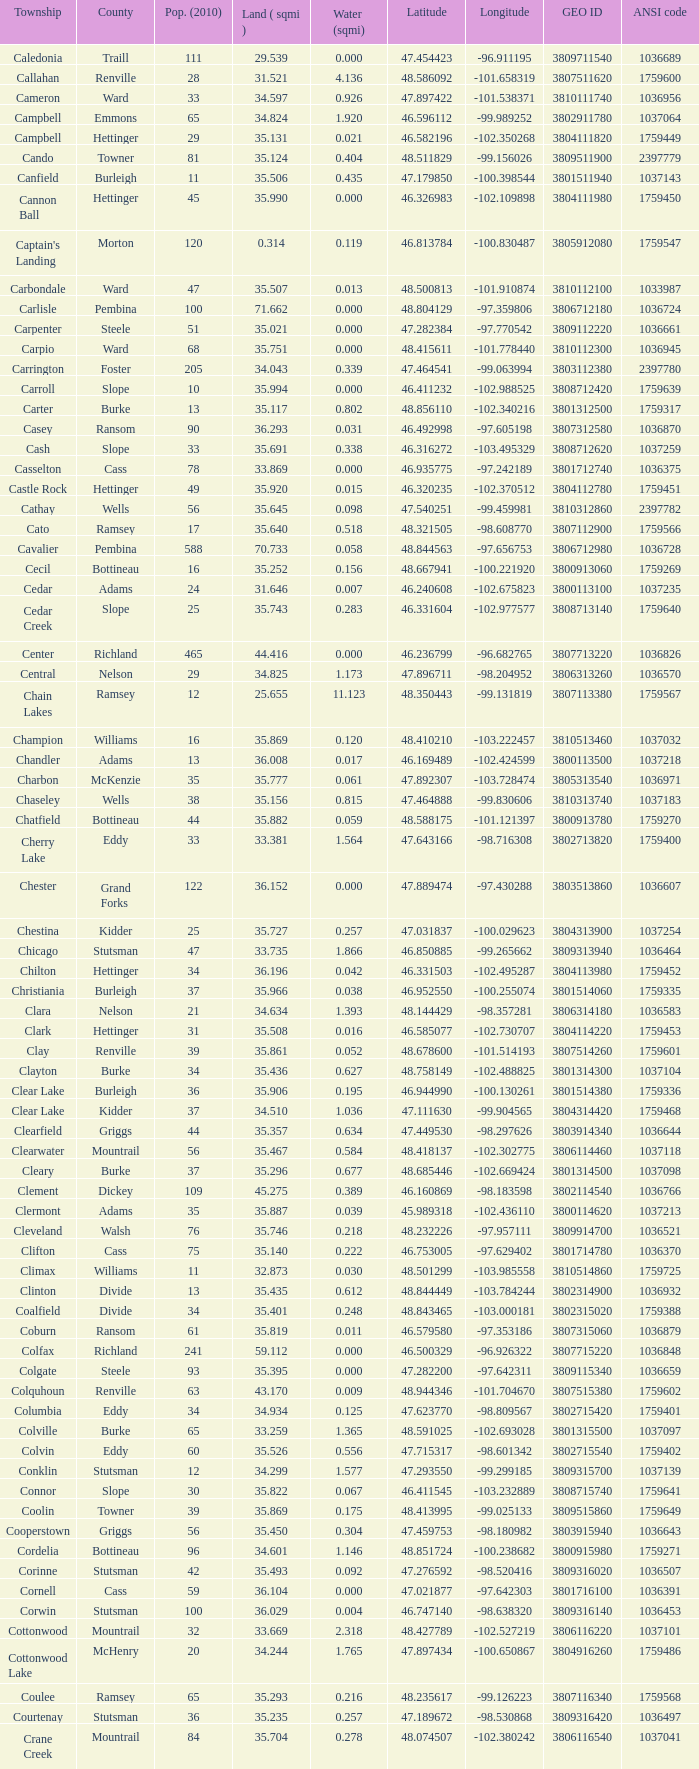What was the locality with a geo id of 3807116660? Creel. 